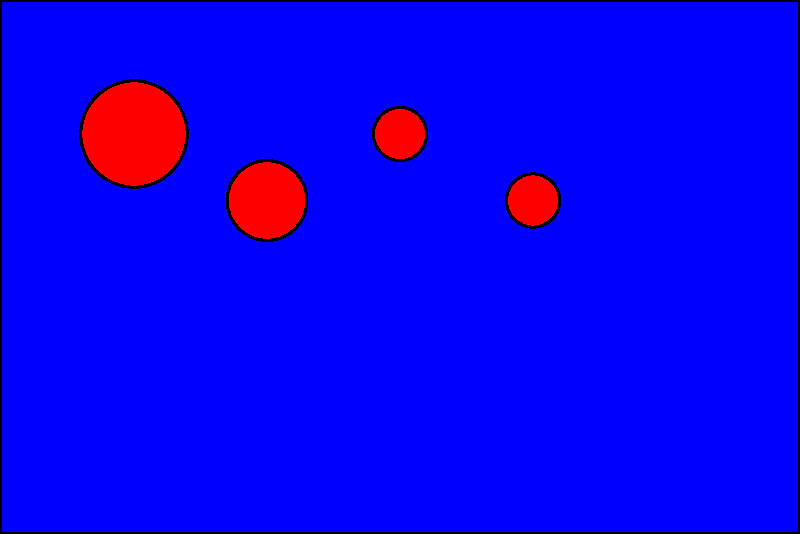Consider the simplified New Zealand flag design shown above. What is the order of the symmetry group for this flag design? To determine the order of the symmetry group for this flag design, let's follow these steps:

1. Identify the symmetries:
   a) Rotational symmetry: The flag has 2-fold rotational symmetry (180° rotation).
   b) Reflection symmetry: The flag has horizontal reflection symmetry.

2. Count the number of distinct symmetry operations:
   a) Identity: Leaving the flag unchanged.
   b) 180° rotation: Rotating the flag 180°.
   c) Horizontal reflection: Flipping the flag horizontally.

3. Calculate the order of the symmetry group:
   The order is equal to the number of distinct symmetry operations.
   In this case, we have 3 distinct operations: identity, 180° rotation, and horizontal reflection.

Therefore, the order of the symmetry group for this flag design is 3.

Note: This simplified flag design is based on the New Zealand flag but does not include all the details of the official flag. The actual New Zealand flag might have additional or different symmetries.
Answer: 3 